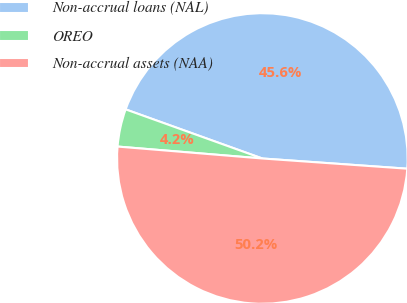Convert chart to OTSL. <chart><loc_0><loc_0><loc_500><loc_500><pie_chart><fcel>Non-accrual loans (NAL)<fcel>OREO<fcel>Non-accrual assets (NAA)<nl><fcel>45.63%<fcel>4.18%<fcel>50.19%<nl></chart> 